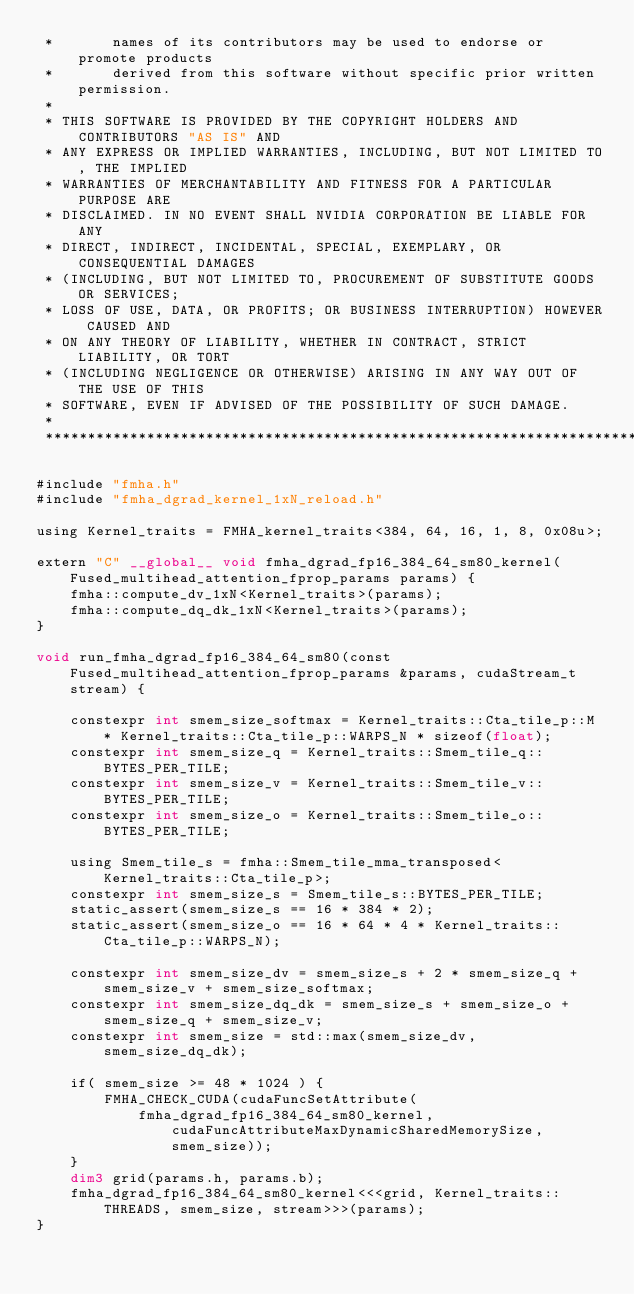<code> <loc_0><loc_0><loc_500><loc_500><_Cuda_> *       names of its contributors may be used to endorse or promote products
 *       derived from this software without specific prior written permission.
 * 
 * THIS SOFTWARE IS PROVIDED BY THE COPYRIGHT HOLDERS AND CONTRIBUTORS "AS IS" AND
 * ANY EXPRESS OR IMPLIED WARRANTIES, INCLUDING, BUT NOT LIMITED TO, THE IMPLIED
 * WARRANTIES OF MERCHANTABILITY AND FITNESS FOR A PARTICULAR PURPOSE ARE
 * DISCLAIMED. IN NO EVENT SHALL NVIDIA CORPORATION BE LIABLE FOR ANY
 * DIRECT, INDIRECT, INCIDENTAL, SPECIAL, EXEMPLARY, OR CONSEQUENTIAL DAMAGES
 * (INCLUDING, BUT NOT LIMITED TO, PROCUREMENT OF SUBSTITUTE GOODS OR SERVICES;
 * LOSS OF USE, DATA, OR PROFITS; OR BUSINESS INTERRUPTION) HOWEVER CAUSED AND
 * ON ANY THEORY OF LIABILITY, WHETHER IN CONTRACT, STRICT LIABILITY, OR TORT
 * (INCLUDING NEGLIGENCE OR OTHERWISE) ARISING IN ANY WAY OUT OF THE USE OF THIS
 * SOFTWARE, EVEN IF ADVISED OF THE POSSIBILITY OF SUCH DAMAGE.
 *
 ******************************************************************************/

#include "fmha.h"
#include "fmha_dgrad_kernel_1xN_reload.h"

using Kernel_traits = FMHA_kernel_traits<384, 64, 16, 1, 8, 0x08u>;

extern "C" __global__ void fmha_dgrad_fp16_384_64_sm80_kernel(Fused_multihead_attention_fprop_params params) {
    fmha::compute_dv_1xN<Kernel_traits>(params);
    fmha::compute_dq_dk_1xN<Kernel_traits>(params);
}

void run_fmha_dgrad_fp16_384_64_sm80(const Fused_multihead_attention_fprop_params &params, cudaStream_t stream) {

    constexpr int smem_size_softmax = Kernel_traits::Cta_tile_p::M * Kernel_traits::Cta_tile_p::WARPS_N * sizeof(float);
    constexpr int smem_size_q = Kernel_traits::Smem_tile_q::BYTES_PER_TILE;
    constexpr int smem_size_v = Kernel_traits::Smem_tile_v::BYTES_PER_TILE;
    constexpr int smem_size_o = Kernel_traits::Smem_tile_o::BYTES_PER_TILE;

    using Smem_tile_s = fmha::Smem_tile_mma_transposed< Kernel_traits::Cta_tile_p>;
    constexpr int smem_size_s = Smem_tile_s::BYTES_PER_TILE;
    static_assert(smem_size_s == 16 * 384 * 2);
    static_assert(smem_size_o == 16 * 64 * 4 * Kernel_traits::Cta_tile_p::WARPS_N);

    constexpr int smem_size_dv = smem_size_s + 2 * smem_size_q + smem_size_v + smem_size_softmax;
    constexpr int smem_size_dq_dk = smem_size_s + smem_size_o + smem_size_q + smem_size_v;
    constexpr int smem_size = std::max(smem_size_dv, smem_size_dq_dk);

    if( smem_size >= 48 * 1024 ) {
        FMHA_CHECK_CUDA(cudaFuncSetAttribute(
            fmha_dgrad_fp16_384_64_sm80_kernel, cudaFuncAttributeMaxDynamicSharedMemorySize, smem_size));
    }
    dim3 grid(params.h, params.b);
    fmha_dgrad_fp16_384_64_sm80_kernel<<<grid, Kernel_traits::THREADS, smem_size, stream>>>(params);
}
</code> 